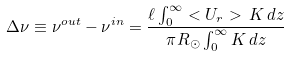<formula> <loc_0><loc_0><loc_500><loc_500>\Delta \nu \equiv \nu ^ { o u t } - \nu ^ { i n } = \frac { \ell \int _ { 0 } ^ { \infty } < U _ { r } > \, K \, d z } { \pi R _ { \odot } \int _ { 0 } ^ { \infty } K \, d z }</formula> 